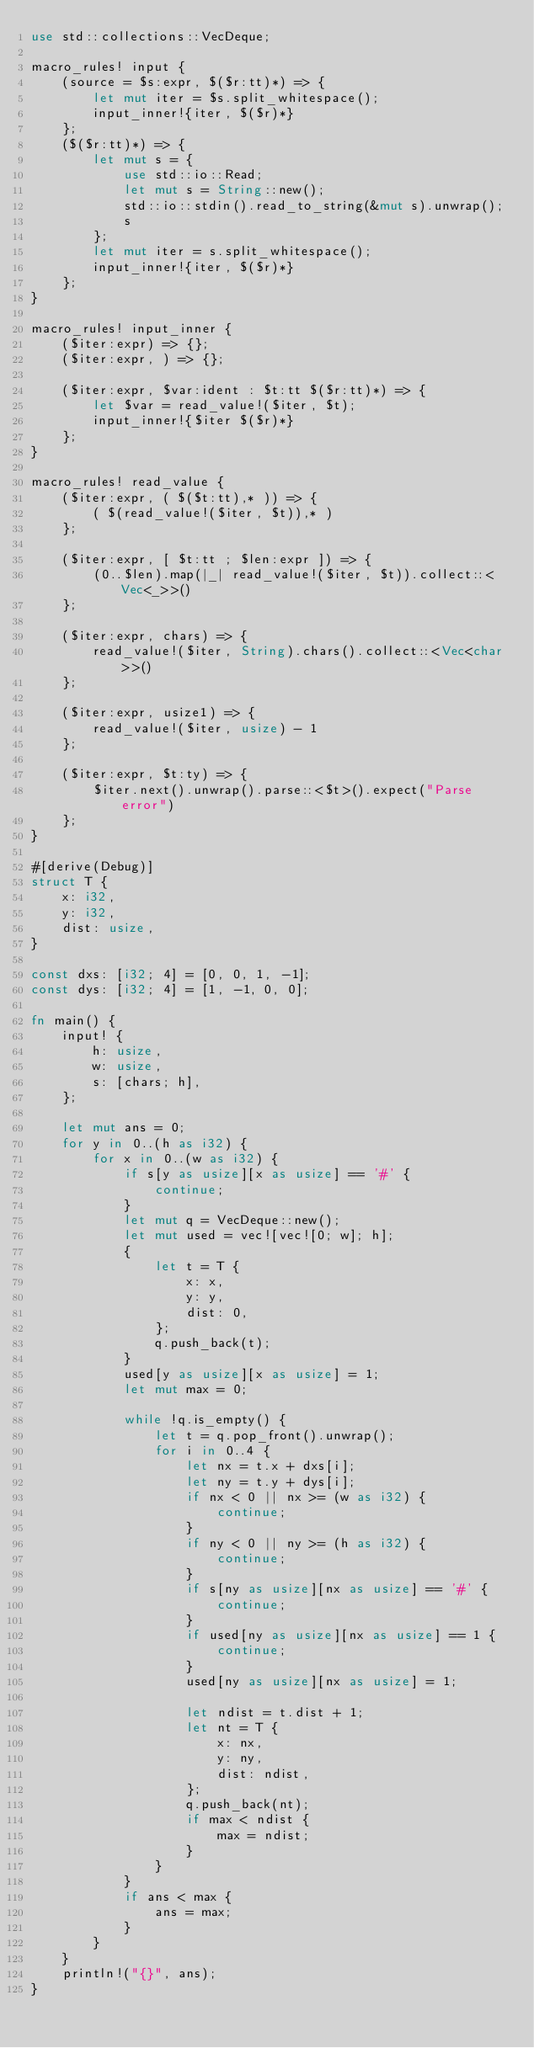Convert code to text. <code><loc_0><loc_0><loc_500><loc_500><_Rust_>use std::collections::VecDeque;

macro_rules! input {
    (source = $s:expr, $($r:tt)*) => {
        let mut iter = $s.split_whitespace();
        input_inner!{iter, $($r)*}
    };
    ($($r:tt)*) => {
        let mut s = {
            use std::io::Read;
            let mut s = String::new();
            std::io::stdin().read_to_string(&mut s).unwrap();
            s
        };
        let mut iter = s.split_whitespace();
        input_inner!{iter, $($r)*}
    };
}

macro_rules! input_inner {
    ($iter:expr) => {};
    ($iter:expr, ) => {};

    ($iter:expr, $var:ident : $t:tt $($r:tt)*) => {
        let $var = read_value!($iter, $t);
        input_inner!{$iter $($r)*}
    };
}

macro_rules! read_value {
    ($iter:expr, ( $($t:tt),* )) => {
        ( $(read_value!($iter, $t)),* )
    };

    ($iter:expr, [ $t:tt ; $len:expr ]) => {
        (0..$len).map(|_| read_value!($iter, $t)).collect::<Vec<_>>()
    };

    ($iter:expr, chars) => {
        read_value!($iter, String).chars().collect::<Vec<char>>()
    };

    ($iter:expr, usize1) => {
        read_value!($iter, usize) - 1
    };

    ($iter:expr, $t:ty) => {
        $iter.next().unwrap().parse::<$t>().expect("Parse error")
    };
}

#[derive(Debug)]
struct T {
    x: i32,
    y: i32,
    dist: usize,
}

const dxs: [i32; 4] = [0, 0, 1, -1];
const dys: [i32; 4] = [1, -1, 0, 0];

fn main() {
    input! {
        h: usize,
        w: usize,
        s: [chars; h],
    };

    let mut ans = 0;
    for y in 0..(h as i32) {
        for x in 0..(w as i32) {
            if s[y as usize][x as usize] == '#' {
                continue;
            }
            let mut q = VecDeque::new();
            let mut used = vec![vec![0; w]; h];
            {
                let t = T {
                    x: x,
                    y: y,
                    dist: 0,
                };
                q.push_back(t);
            }
            used[y as usize][x as usize] = 1;
            let mut max = 0;

            while !q.is_empty() {
                let t = q.pop_front().unwrap();
                for i in 0..4 {
                    let nx = t.x + dxs[i];
                    let ny = t.y + dys[i];
                    if nx < 0 || nx >= (w as i32) {
                        continue;
                    }
                    if ny < 0 || ny >= (h as i32) {
                        continue;
                    }
                    if s[ny as usize][nx as usize] == '#' {
                        continue;
                    }
                    if used[ny as usize][nx as usize] == 1 {
                        continue;
                    }
                    used[ny as usize][nx as usize] = 1;

                    let ndist = t.dist + 1;
                    let nt = T {
                        x: nx,
                        y: ny,
                        dist: ndist,
                    };
                    q.push_back(nt);
                    if max < ndist {
                        max = ndist;
                    }
                }
            }
            if ans < max {
                ans = max;
            }
        }
    }
    println!("{}", ans);
}
</code> 